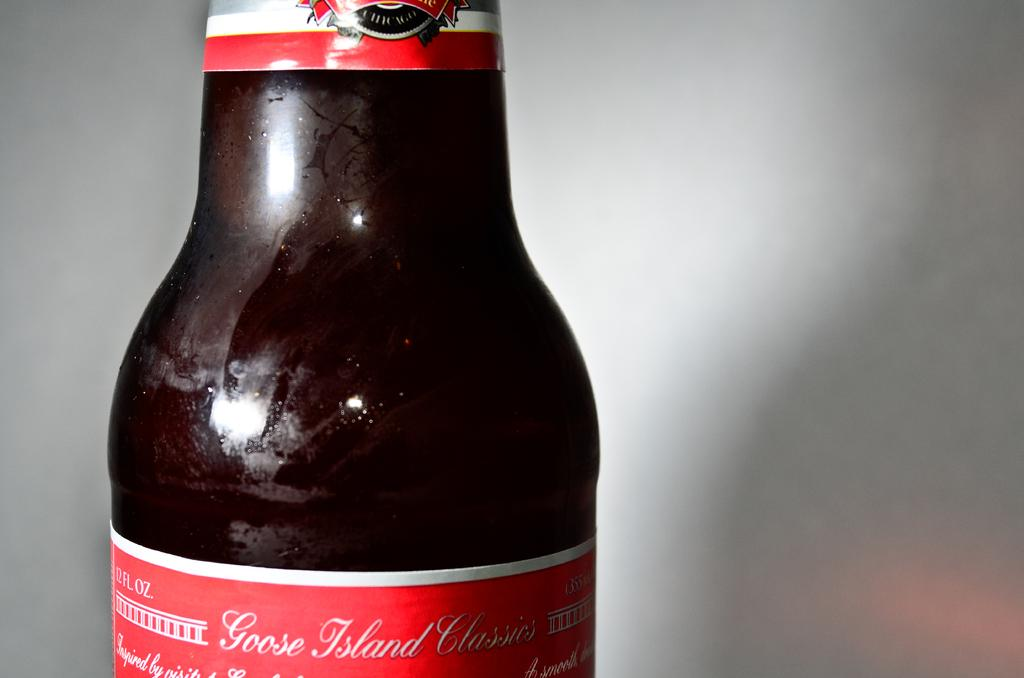<image>
Present a compact description of the photo's key features. A brown bottle of Goose Island Classic with a red label. 